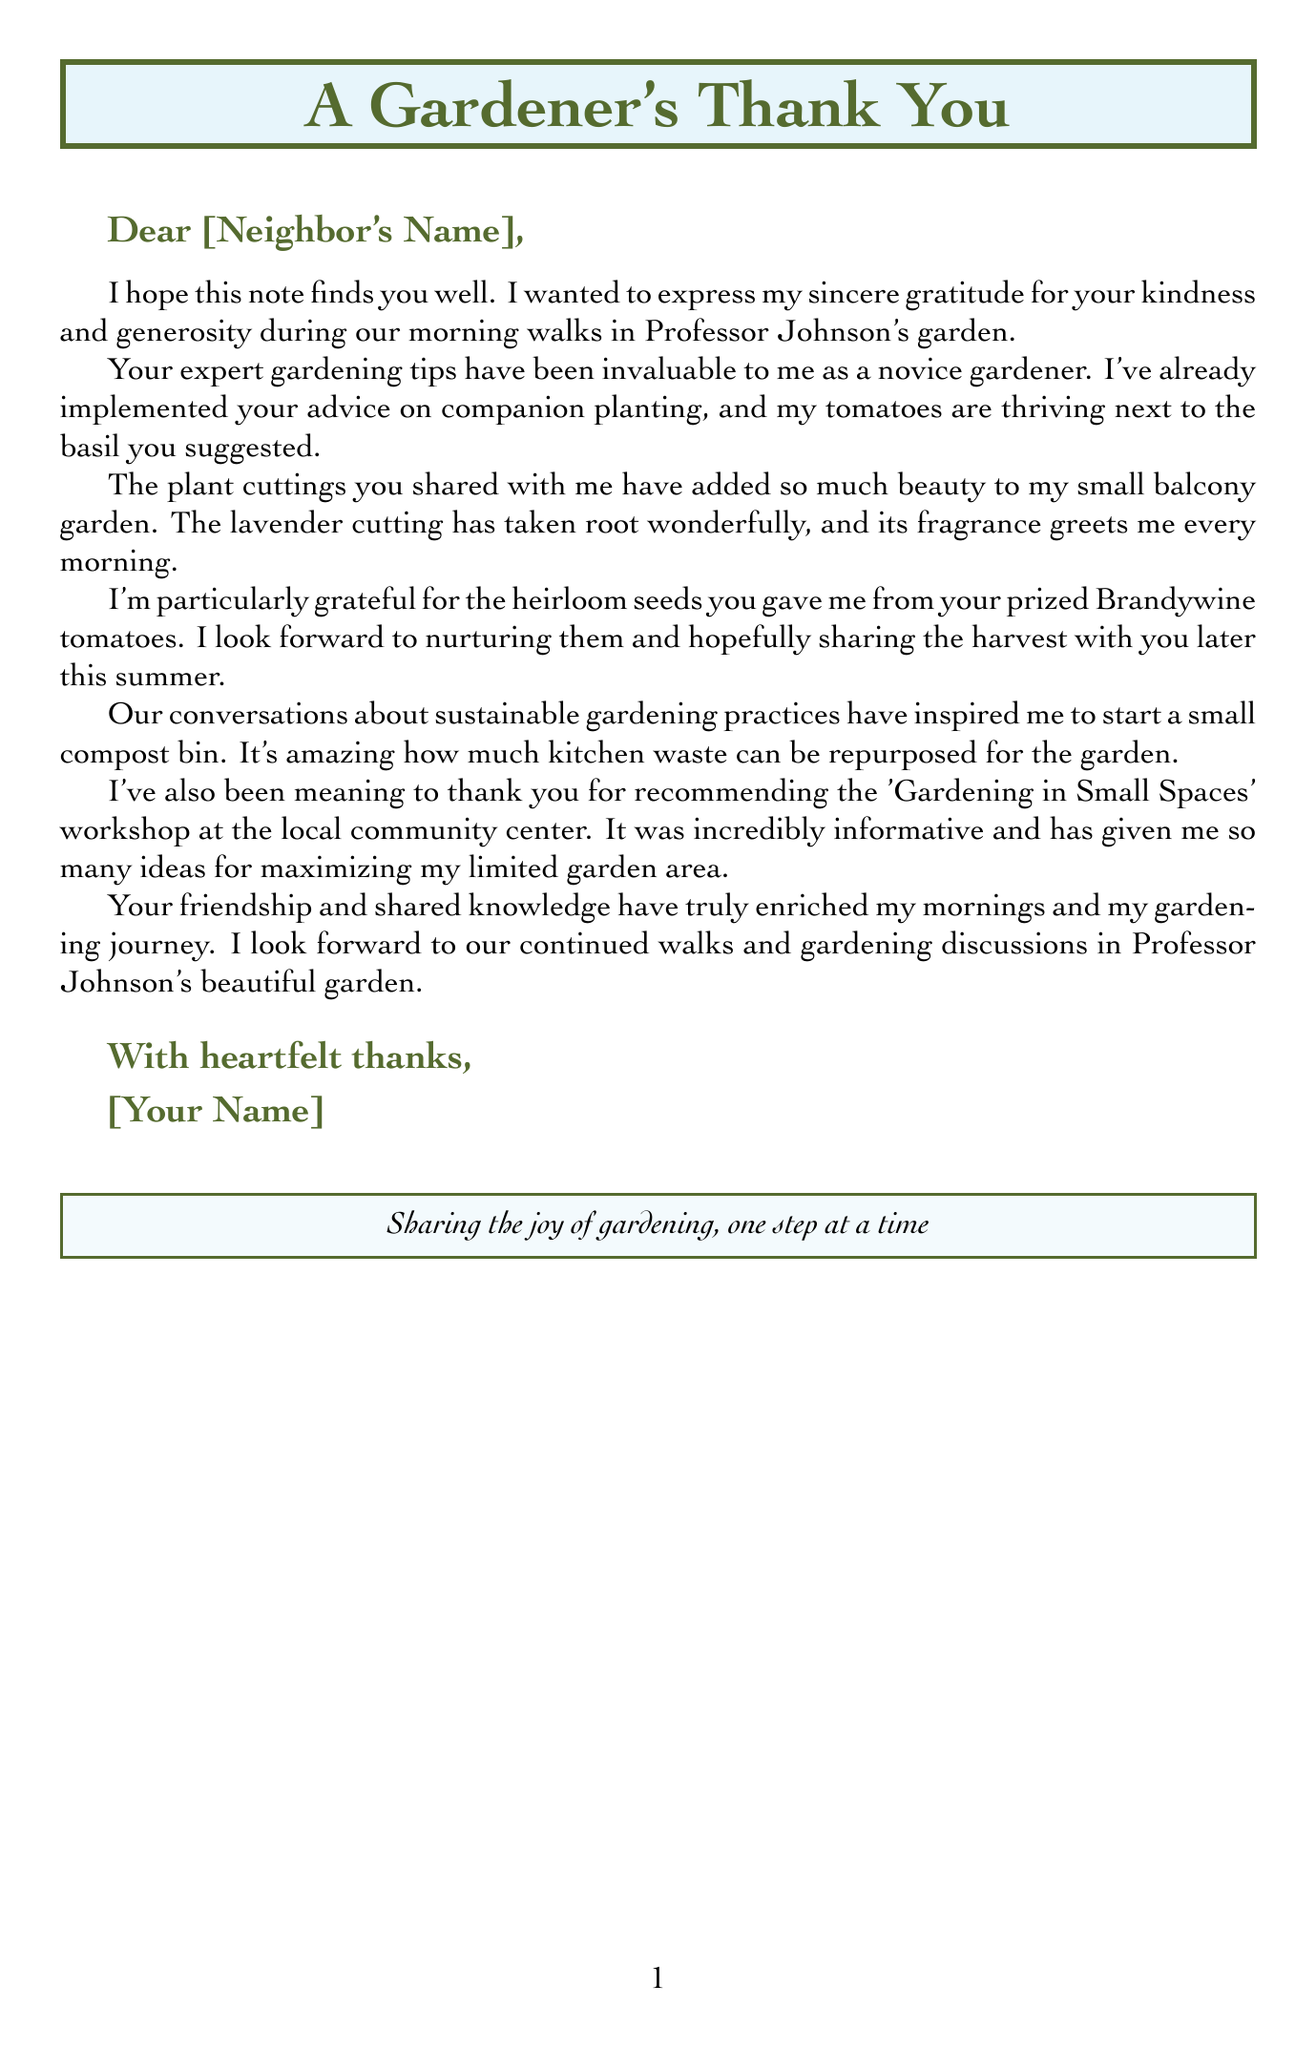What is the recipient's name? The document provides a placeholder for the recipient's name, which would be filled in before sending the note.
Answer: [Neighbor's Name] What gardening advice was mentioned for planting tomatoes? The letter specifically mentions the advice given on companion planting with basil, which helps tomatoes thrive.
Answer: Companion planting (tomatoes and basil) What has the lavender cutting done in the writer's garden? The letter states that the lavender cutting has taken root and offers a pleasant fragrance every morning.
Answer: Taken root wonderfully What heirloom seeds were shared? The letter mentions that the heirloom seeds specifically noted were from Brandywine tomatoes given to the writer.
Answer: Brandywine tomatoes What new gardening project has the writer started? The letter mentions the initiation of a composting project that was inspired by discussions on sustainable practices.
Answer: Small compost bin What was recommended for additional gardening education? The letter refers to a workshop that was recommended for learning about gardening in small spaces.
Answer: Gardening in Small Spaces workshop How has the friendship enriched the writer's experience? The writer expresses that the shared knowledge and friendship have enriched their mornings and gardening journey.
Answer: Enriched my mornings and my gardening journey Where do the morning walks take place? The letter states the location of the morning walks as Professor Johnson's garden.
Answer: Professor Johnson's garden 